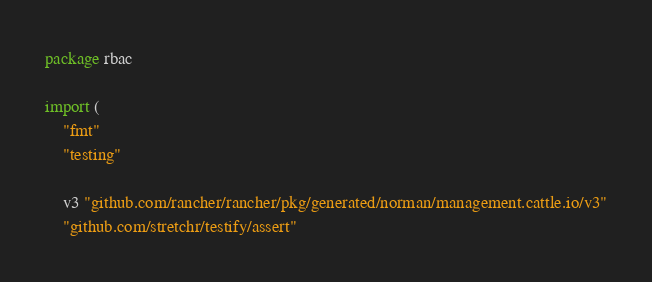Convert code to text. <code><loc_0><loc_0><loc_500><loc_500><_Go_>package rbac

import (
	"fmt"
	"testing"

	v3 "github.com/rancher/rancher/pkg/generated/norman/management.cattle.io/v3"
	"github.com/stretchr/testify/assert"</code> 